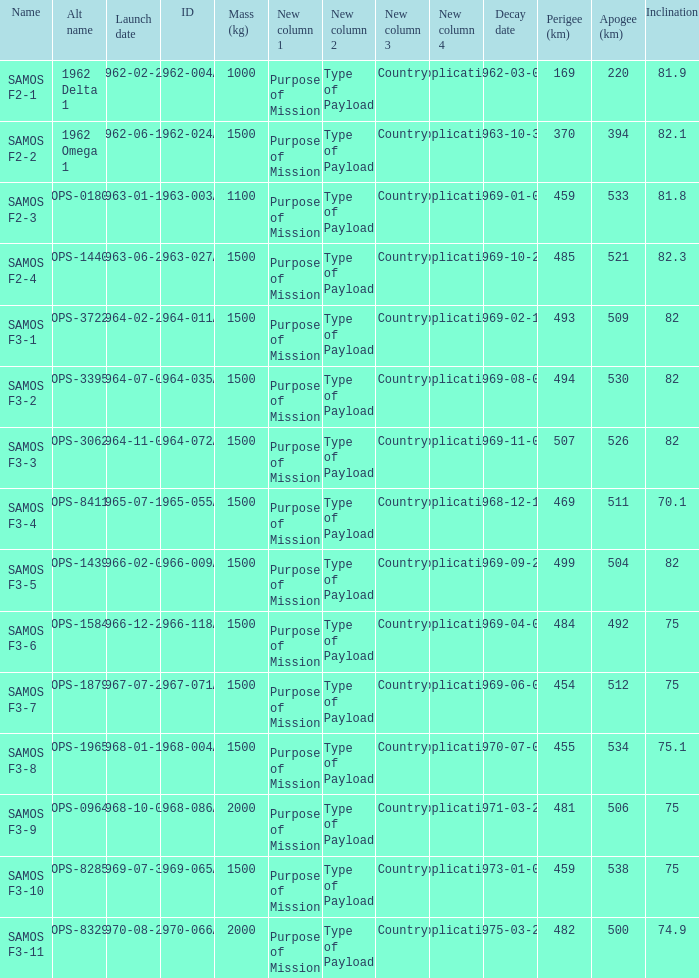How many alt names does 1964-011a have? 1.0. 